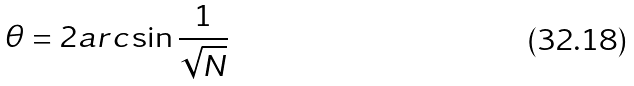<formula> <loc_0><loc_0><loc_500><loc_500>\theta = 2 a r c \sin \frac { 1 } { \sqrt { N } }</formula> 